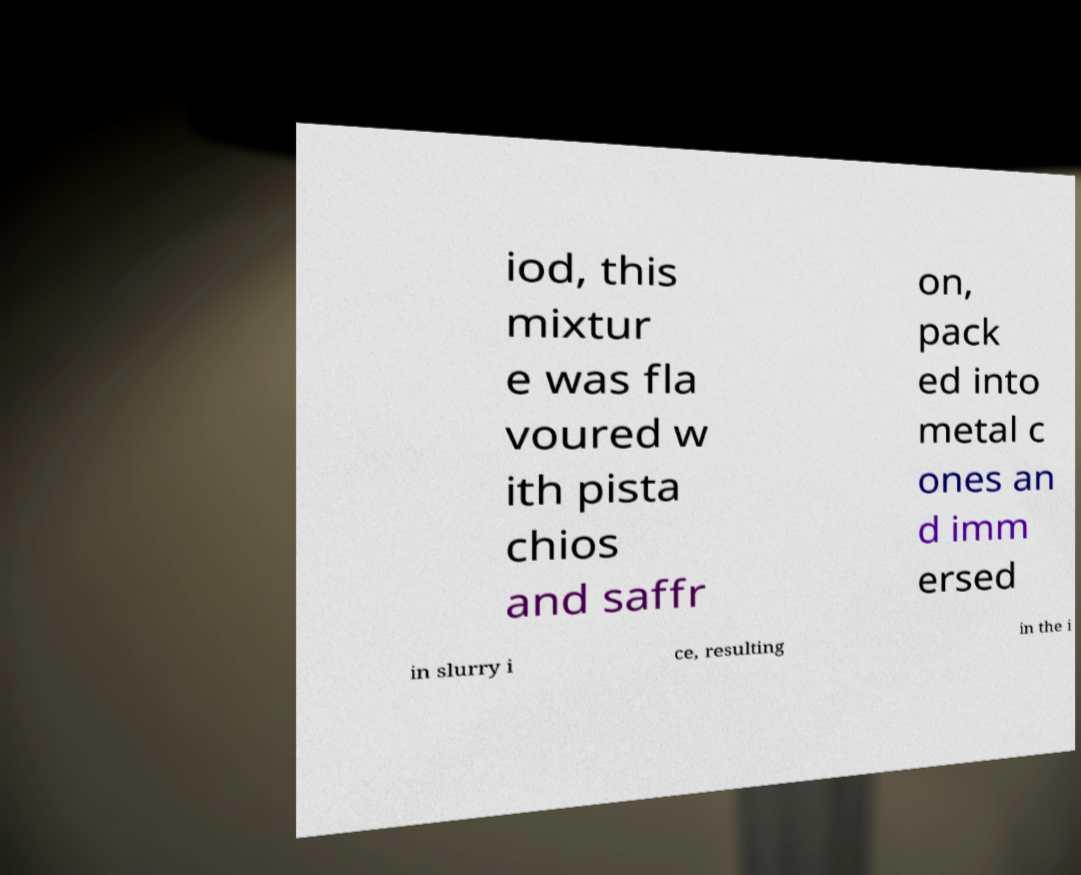I need the written content from this picture converted into text. Can you do that? iod, this mixtur e was fla voured w ith pista chios and saffr on, pack ed into metal c ones an d imm ersed in slurry i ce, resulting in the i 